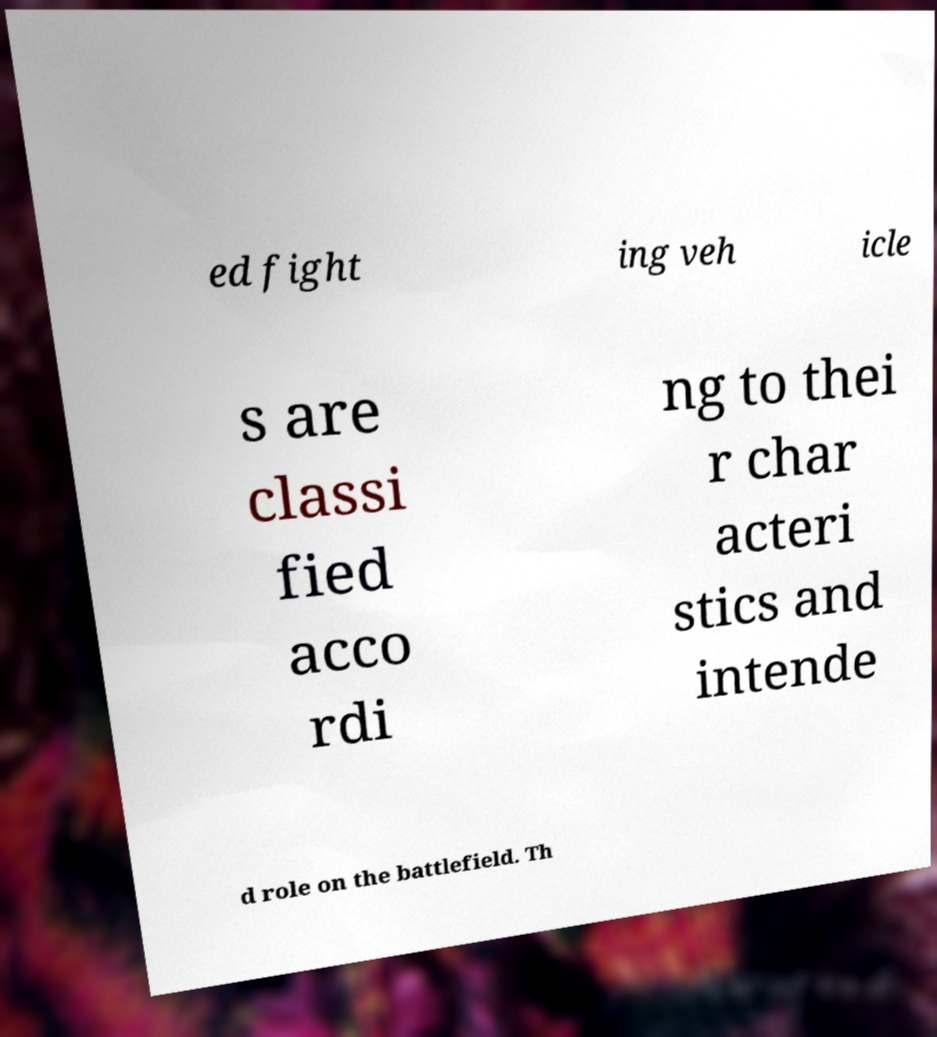For documentation purposes, I need the text within this image transcribed. Could you provide that? ed fight ing veh icle s are classi fied acco rdi ng to thei r char acteri stics and intende d role on the battlefield. Th 